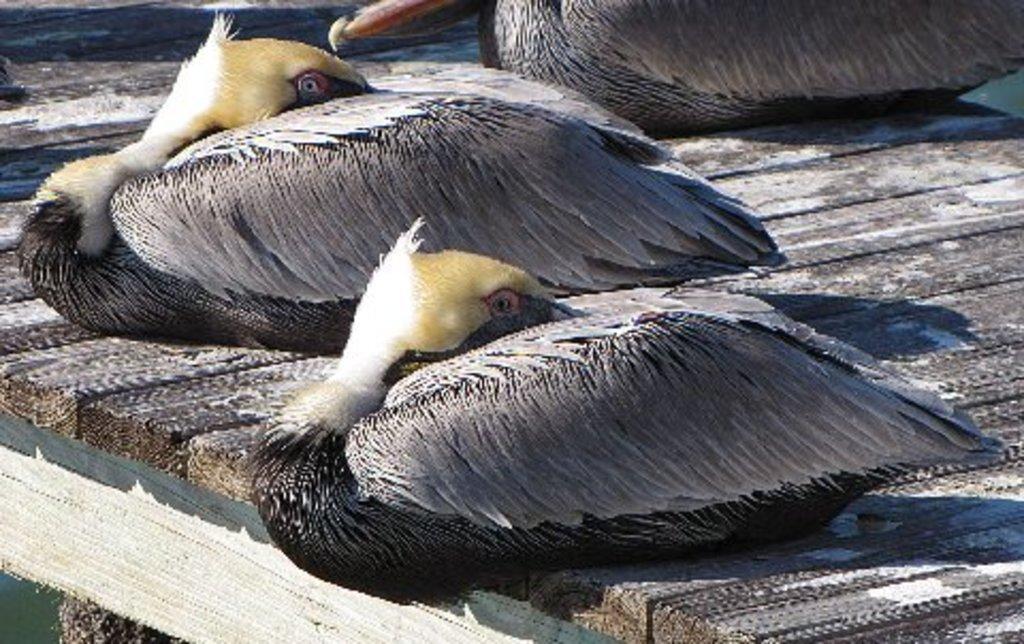Can you describe this image briefly? There are birds on the wooden surface. 